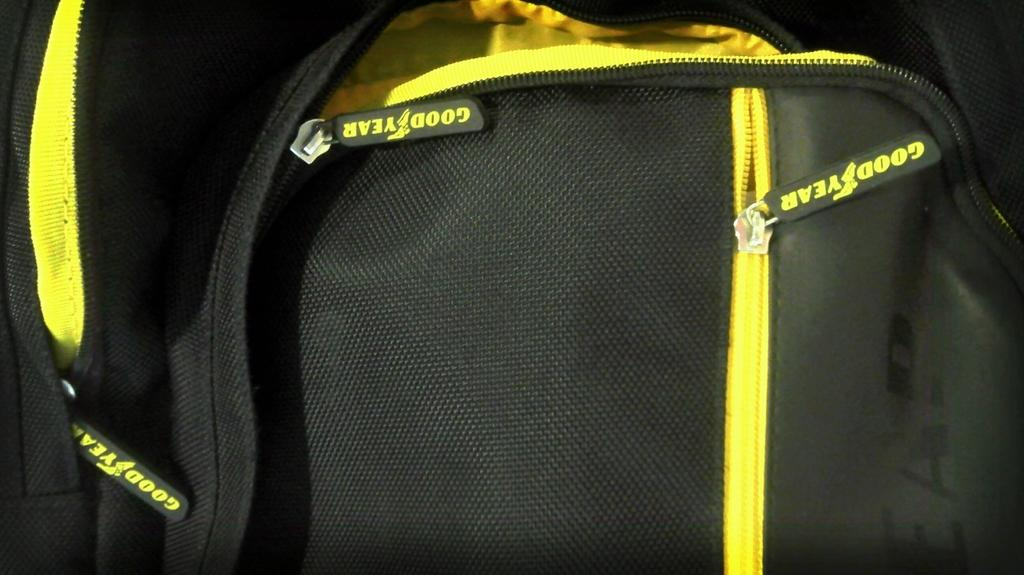What object is present in the picture? There is a bag in the picture. What colors are visible on the bag? The bag has black and yellow colors. What type of bag does it resemble? The bag resembles a college bag. What can be seen on the zip of the bag? On the zip of the bag, there are words that might spell "Good Year," which could be the brand name. How much does the door cost in the image? There is no door present in the image; it only features a bag. 